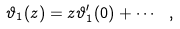Convert formula to latex. <formula><loc_0><loc_0><loc_500><loc_500>\vartheta _ { 1 } ( z ) = z \vartheta ^ { \prime } _ { 1 } ( 0 ) + \cdots \ ,</formula> 